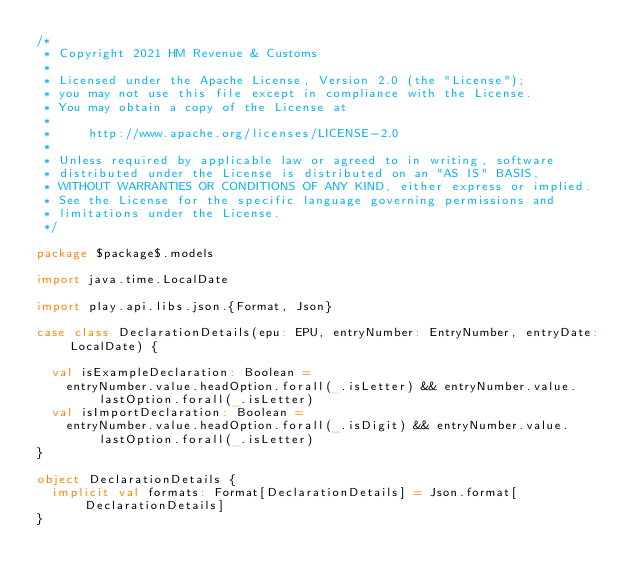<code> <loc_0><loc_0><loc_500><loc_500><_Scala_>/*
 * Copyright 2021 HM Revenue & Customs
 *
 * Licensed under the Apache License, Version 2.0 (the "License");
 * you may not use this file except in compliance with the License.
 * You may obtain a copy of the License at
 *
 *     http://www.apache.org/licenses/LICENSE-2.0
 *
 * Unless required by applicable law or agreed to in writing, software
 * distributed under the License is distributed on an "AS IS" BASIS,
 * WITHOUT WARRANTIES OR CONDITIONS OF ANY KIND, either express or implied.
 * See the License for the specific language governing permissions and
 * limitations under the License.
 */

package $package$.models

import java.time.LocalDate

import play.api.libs.json.{Format, Json}

case class DeclarationDetails(epu: EPU, entryNumber: EntryNumber, entryDate: LocalDate) {

  val isExampleDeclaration: Boolean =
    entryNumber.value.headOption.forall(_.isLetter) && entryNumber.value.lastOption.forall(_.isLetter)
  val isImportDeclaration: Boolean =
    entryNumber.value.headOption.forall(_.isDigit) && entryNumber.value.lastOption.forall(_.isLetter)
}

object DeclarationDetails {
  implicit val formats: Format[DeclarationDetails] = Json.format[DeclarationDetails]
}
</code> 